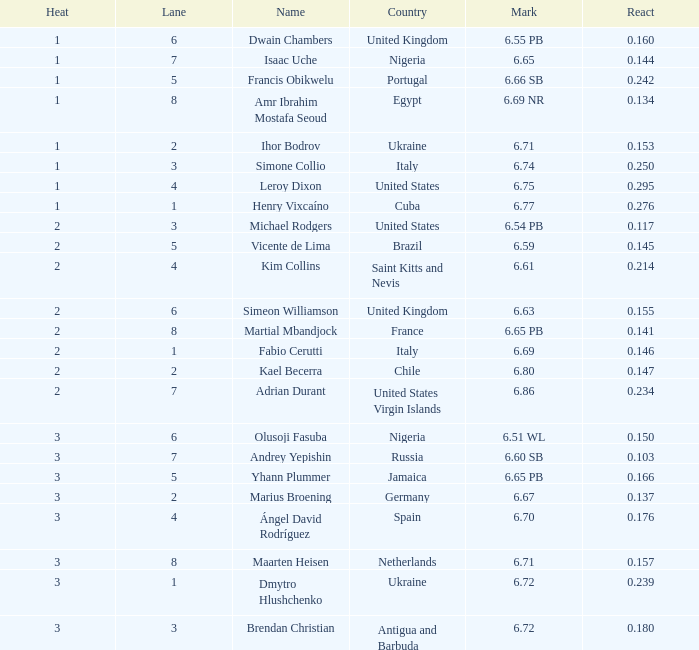What does heat represent when mark has a value of 6.69? 2.0. 